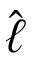Convert formula to latex. <formula><loc_0><loc_0><loc_500><loc_500>\hat { \ell }</formula> 